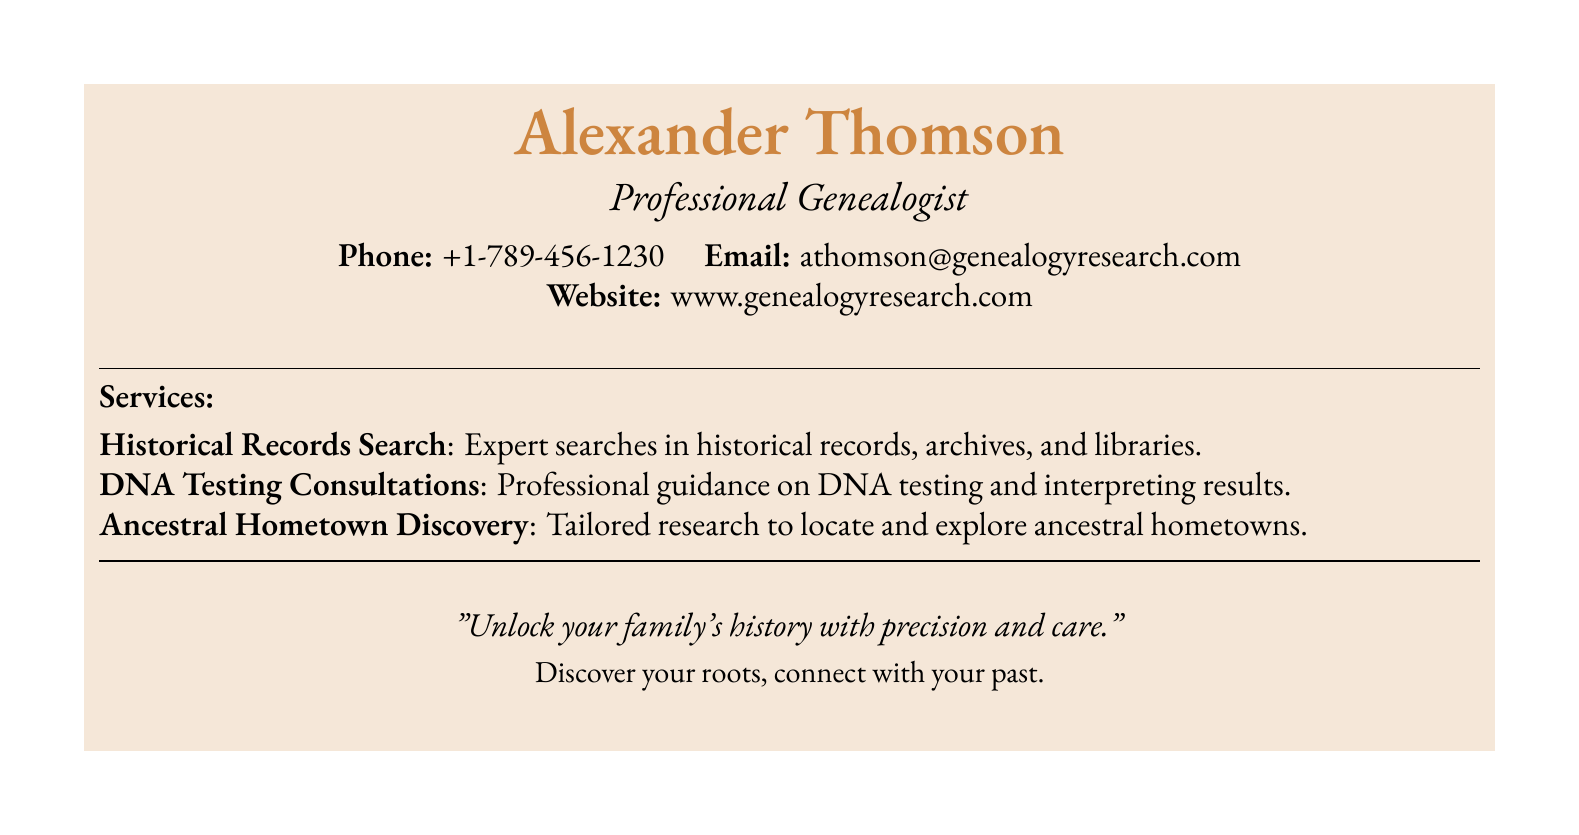What is the name of the professional genealogist? The name is prominently displayed at the top of the document, indicating the identity of the genealogist.
Answer: Alexander Thomson What is the phone number listed on the card? The document specifies contact information, including a phone number for potential clients.
Answer: +1-789-456-1230 What type of consultations does the service offer? One of the services clearly mentioned pertains to providing professional guidance in a specific area.
Answer: DNA Testing Consultations What is the website address provided? The document includes a web address where more information can be found.
Answer: www.genealogyresearch.com What is the theme of the motto presented? The motto reflects the essence of the services offered and is a call to action for prospective clients.
Answer: Unlock your family's history with precision and care How many specialized services are listed? The document details the specific offerings of the genealogist which can be tallied for clarity.
Answer: 3 What type of document is presented here? This document serves a specific purpose and is designed to present contact and service information professionally.
Answer: Business card Which color theme is used in the document? The color of the background and text aligns with a vintage aesthetic, enhancing the overall presentation.
Answer: Vintage 